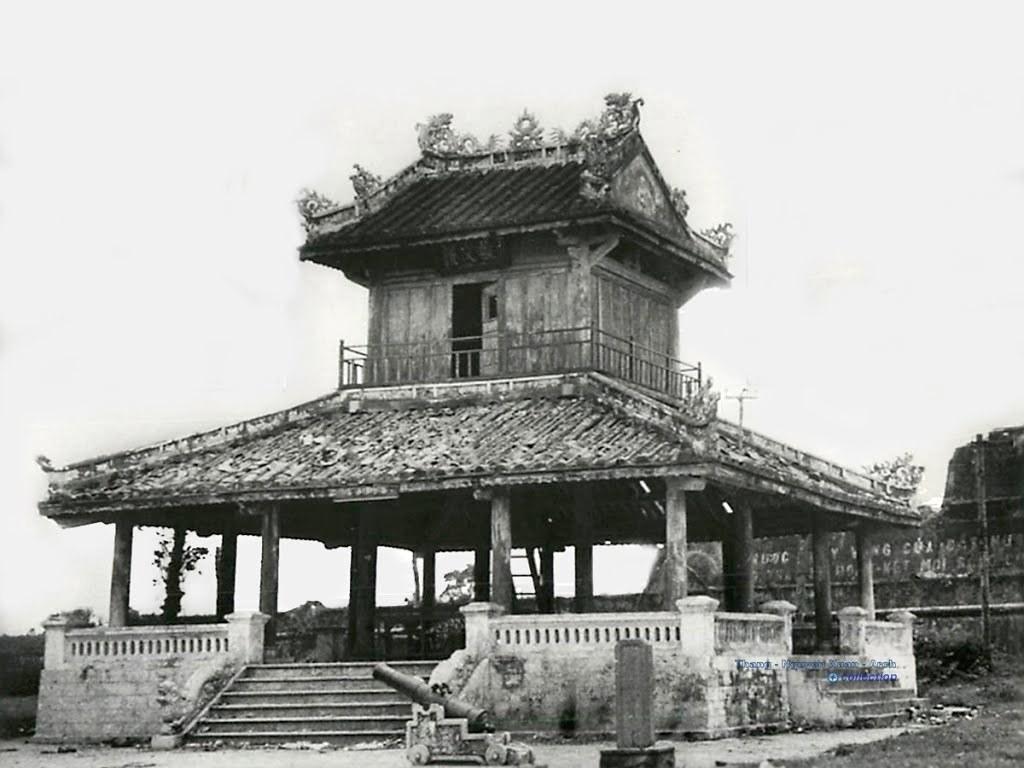Please provide a concise description of this image. It is a black and white picture. In the picture we can see some steps and fencing and there is a shed. Behind the shed there's sky. 